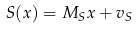Convert formula to latex. <formula><loc_0><loc_0><loc_500><loc_500>S ( x ) = M _ { S } x + v _ { S }</formula> 